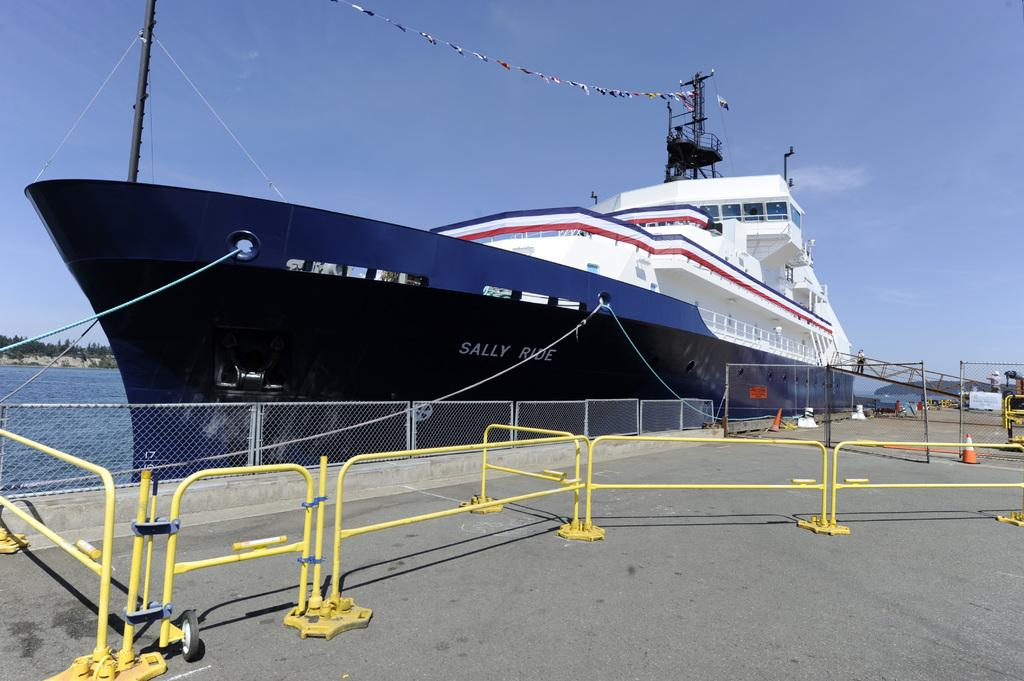What type of barrier can be seen in the image? There is a fence in the image. What mode of transportation is present in the image? There is a boat in the image. What safety device is visible in the image? There is a traffic cone in the image. What type of signage is present in the image? There is a poster in the image. What natural feature is visible in the image? There is water visible in the image. What type of vegetation can be seen in the background of the image? There are trees in the background of the image. What is visible at the top of the image? The sky is visible at the top of the image. Can you tell me how many times the queen smiles in the image? There is no queen present in the image, so it is not possible to determine how many times she smiles. What type of seafood is visible in the image? There is no seafood, specifically clams, present in the image. 